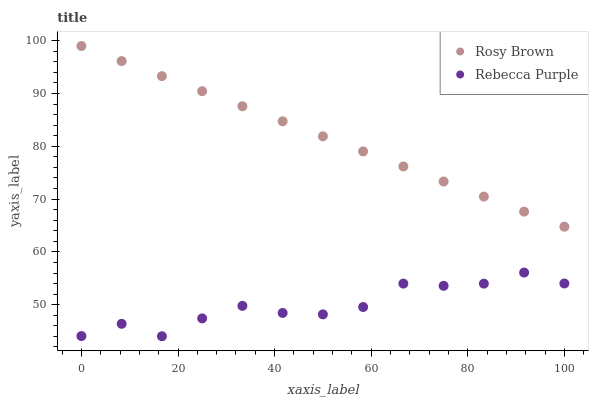Does Rebecca Purple have the minimum area under the curve?
Answer yes or no. Yes. Does Rosy Brown have the maximum area under the curve?
Answer yes or no. Yes. Does Rebecca Purple have the maximum area under the curve?
Answer yes or no. No. Is Rosy Brown the smoothest?
Answer yes or no. Yes. Is Rebecca Purple the roughest?
Answer yes or no. Yes. Is Rebecca Purple the smoothest?
Answer yes or no. No. Does Rebecca Purple have the lowest value?
Answer yes or no. Yes. Does Rosy Brown have the highest value?
Answer yes or no. Yes. Does Rebecca Purple have the highest value?
Answer yes or no. No. Is Rebecca Purple less than Rosy Brown?
Answer yes or no. Yes. Is Rosy Brown greater than Rebecca Purple?
Answer yes or no. Yes. Does Rebecca Purple intersect Rosy Brown?
Answer yes or no. No. 